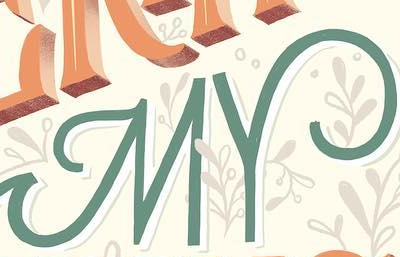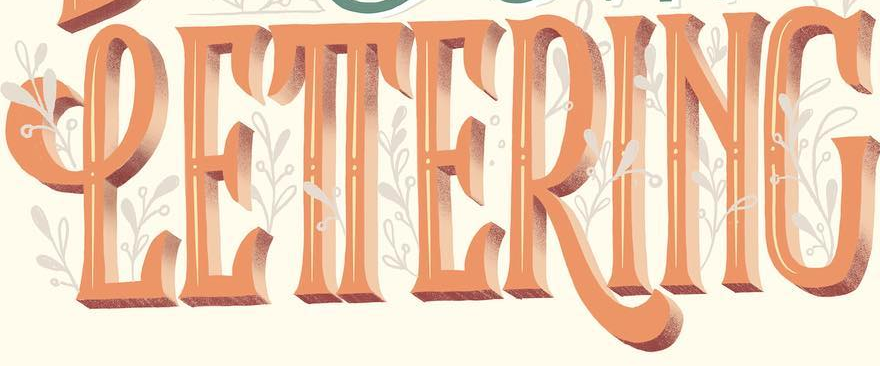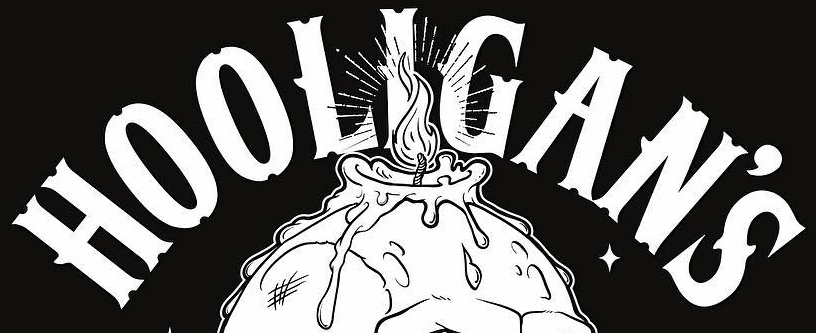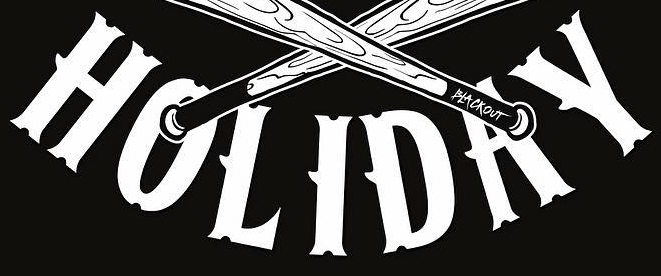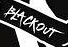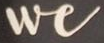What text appears in these images from left to right, separated by a semicolon? MY; LETTERING; HOOLIGAN'S; HOLIDAY; BLACKOUT; We 